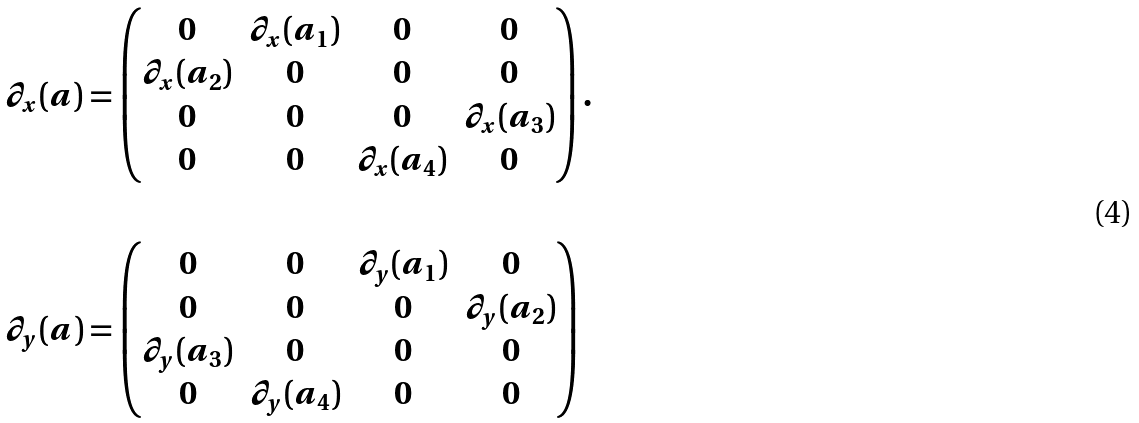<formula> <loc_0><loc_0><loc_500><loc_500>& \partial _ { x } ( a ) = \left ( \begin{matrix} 0 & \partial _ { x } ( a _ { 1 } ) & 0 & 0 \\ \partial _ { x } ( a _ { 2 } ) & 0 & 0 & 0 \\ 0 & 0 & 0 & \partial _ { x } ( a _ { 3 } ) \\ 0 & 0 & \partial _ { x } ( a _ { 4 } ) & 0 \end{matrix} \right ) . \\ \\ & \partial _ { y } ( a ) = \left ( \begin{matrix} 0 & 0 & \partial _ { y } ( a _ { 1 } ) & 0 \\ 0 & 0 & 0 & \partial _ { y } ( a _ { 2 } ) \\ \partial _ { y } ( a _ { 3 } ) & 0 & 0 & 0 \\ 0 & \partial _ { y } ( a _ { 4 } ) & 0 & 0 \end{matrix} \right )</formula> 